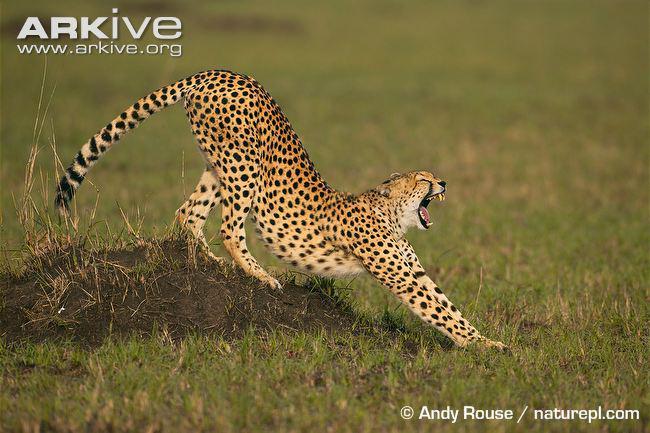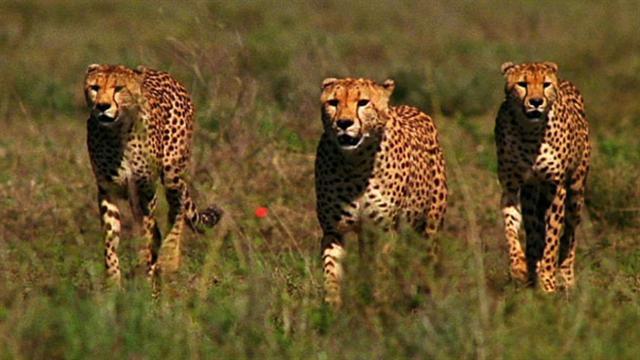The first image is the image on the left, the second image is the image on the right. Considering the images on both sides, is "An image shows at least one cheetah near an animal with curved horns." valid? Answer yes or no. No. The first image is the image on the left, the second image is the image on the right. Analyze the images presented: Is the assertion "there are exactly three animals in the image on the right" valid? Answer yes or no. Yes. 